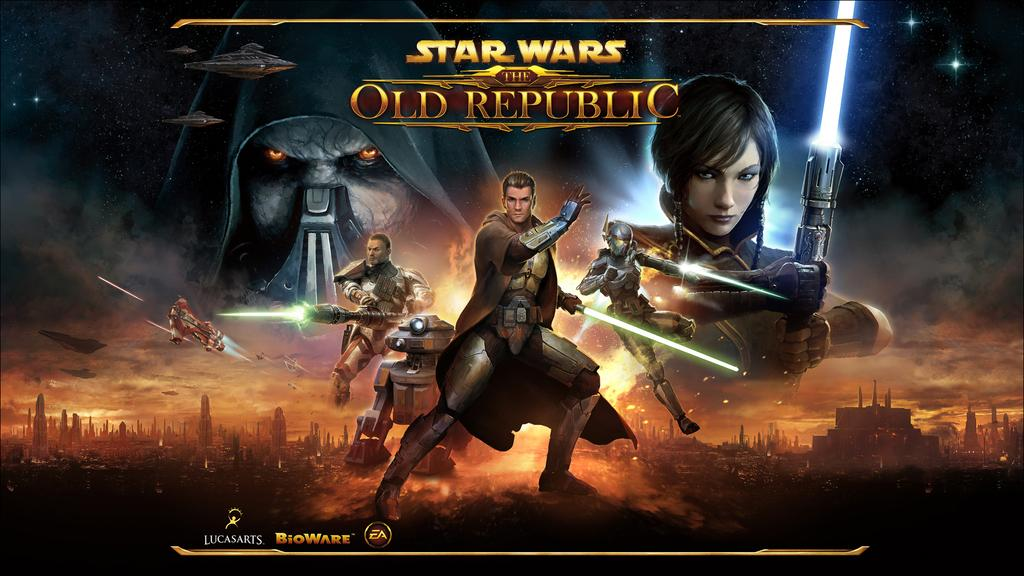<image>
Summarize the visual content of the image. A poster depicts an outerspace scene featuring characters from a Star Wars video game called The Old Republic. 